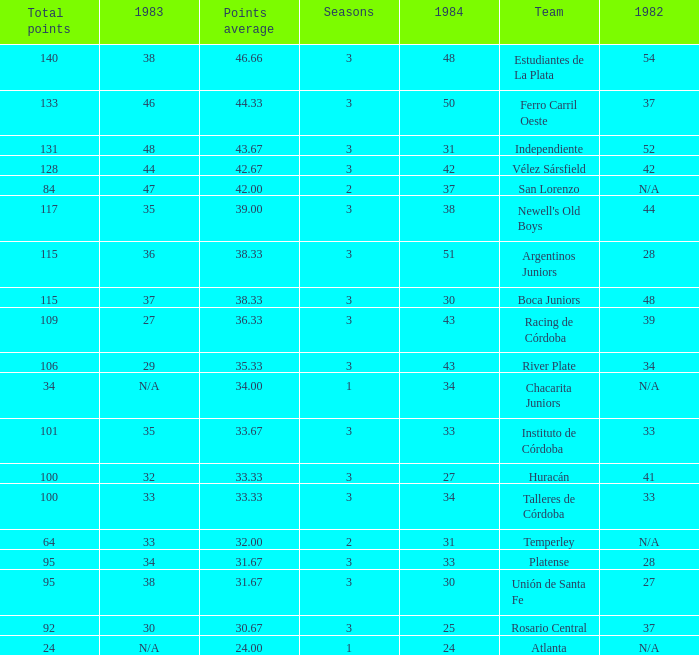What is the total for 1984 for the team with 100 points total and more than 3 seasons? None. 